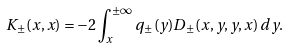<formula> <loc_0><loc_0><loc_500><loc_500>K _ { \pm } ( x , x ) = - 2 \int _ { x } ^ { \pm \infty } q _ { \pm } ( y ) D _ { \pm } ( x , y , y , x ) \, d y .</formula> 